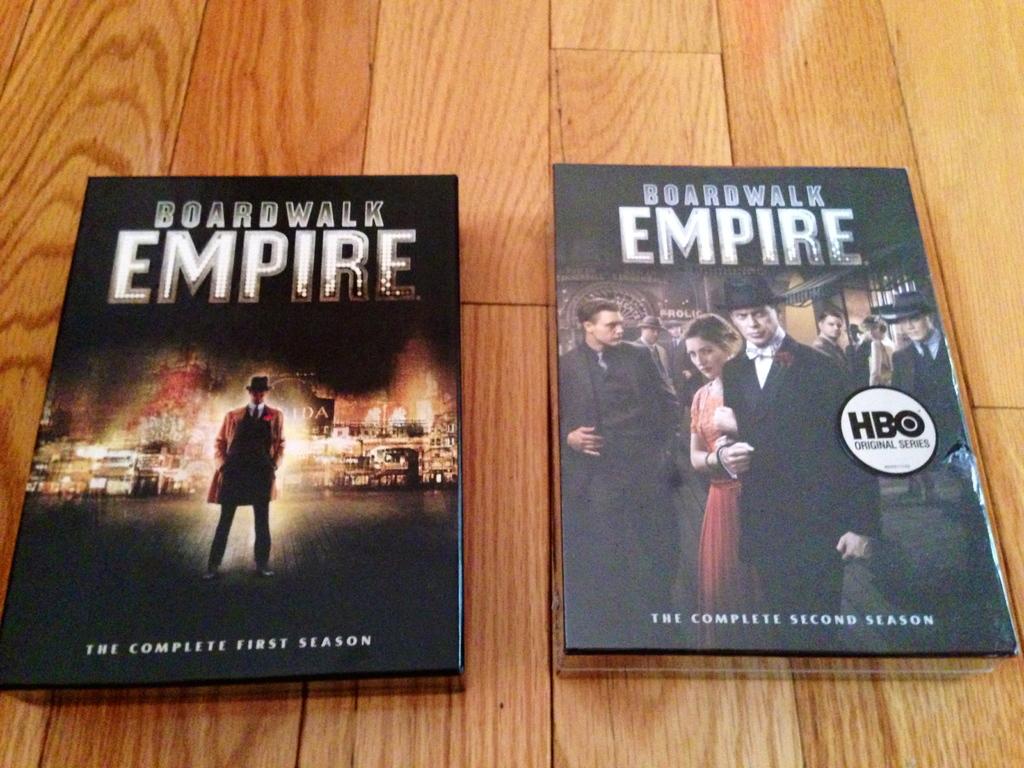What colour is the womans dress?
Give a very brief answer. Answering does not require reading text in the image. 